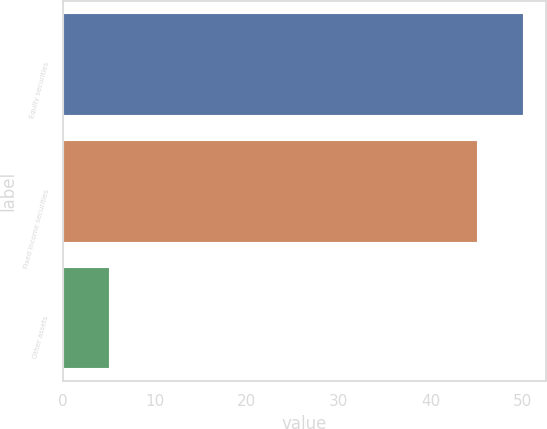<chart> <loc_0><loc_0><loc_500><loc_500><bar_chart><fcel>Equity securities<fcel>Fixed income securities<fcel>Other assets<nl><fcel>50<fcel>45<fcel>5<nl></chart> 